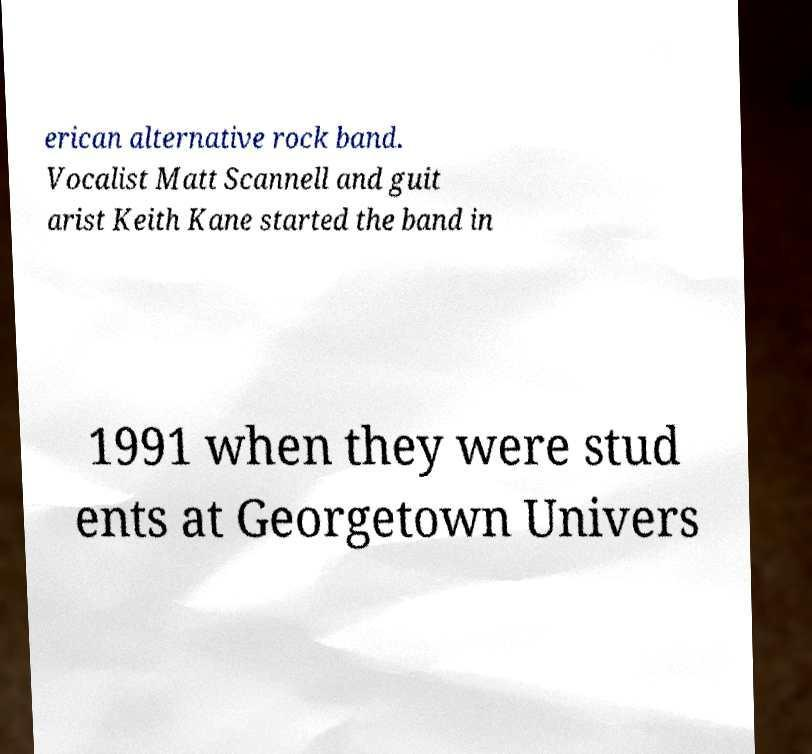Can you read and provide the text displayed in the image?This photo seems to have some interesting text. Can you extract and type it out for me? erican alternative rock band. Vocalist Matt Scannell and guit arist Keith Kane started the band in 1991 when they were stud ents at Georgetown Univers 